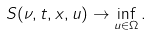<formula> <loc_0><loc_0><loc_500><loc_500>S ( \nu , t , x , u ) \to \inf _ { u \in \Omega } .</formula> 